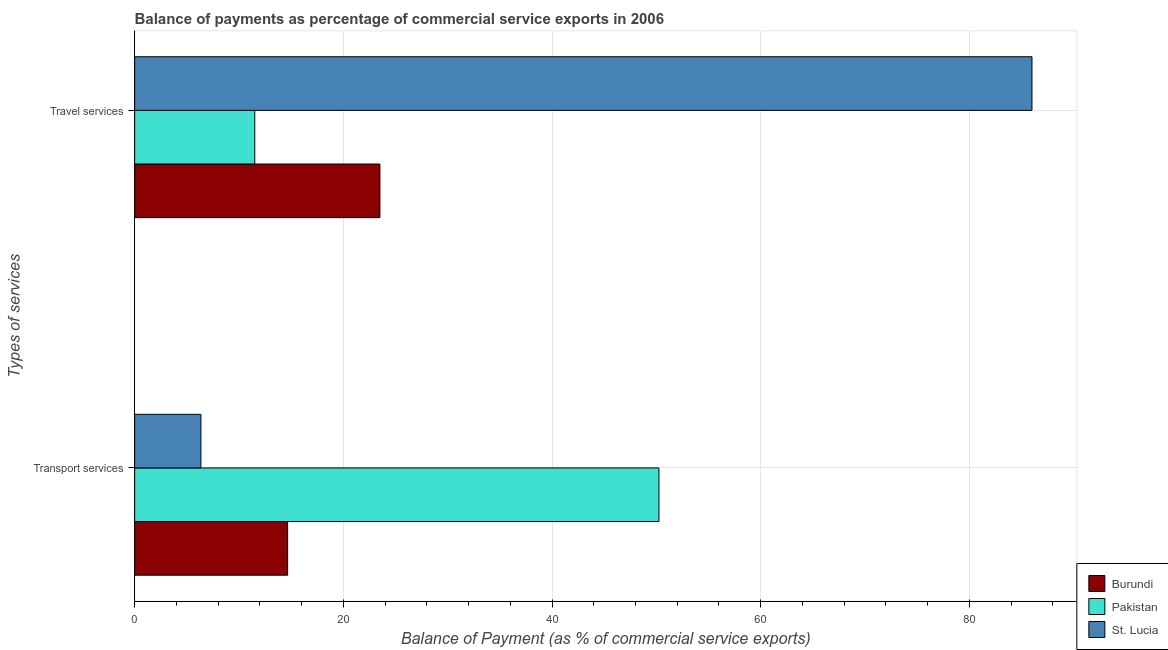How many different coloured bars are there?
Offer a very short reply. 3. How many groups of bars are there?
Give a very brief answer. 2. Are the number of bars per tick equal to the number of legend labels?
Your answer should be compact. Yes. What is the label of the 2nd group of bars from the top?
Your answer should be very brief. Transport services. What is the balance of payments of transport services in Pakistan?
Offer a very short reply. 50.25. Across all countries, what is the maximum balance of payments of travel services?
Provide a succinct answer. 86. Across all countries, what is the minimum balance of payments of travel services?
Offer a terse response. 11.51. In which country was the balance of payments of travel services maximum?
Give a very brief answer. St. Lucia. In which country was the balance of payments of transport services minimum?
Offer a terse response. St. Lucia. What is the total balance of payments of transport services in the graph?
Your answer should be compact. 71.26. What is the difference between the balance of payments of transport services in St. Lucia and that in Pakistan?
Give a very brief answer. -43.9. What is the difference between the balance of payments of travel services in St. Lucia and the balance of payments of transport services in Burundi?
Give a very brief answer. 71.34. What is the average balance of payments of travel services per country?
Your answer should be compact. 40.34. What is the difference between the balance of payments of transport services and balance of payments of travel services in Burundi?
Offer a terse response. -8.84. What is the ratio of the balance of payments of transport services in St. Lucia to that in Burundi?
Offer a very short reply. 0.43. Is the balance of payments of transport services in St. Lucia less than that in Burundi?
Ensure brevity in your answer.  Yes. In how many countries, is the balance of payments of travel services greater than the average balance of payments of travel services taken over all countries?
Keep it short and to the point. 1. What does the 3rd bar from the top in Transport services represents?
Offer a terse response. Burundi. What does the 3rd bar from the bottom in Transport services represents?
Provide a succinct answer. St. Lucia. How many bars are there?
Provide a succinct answer. 6. Are all the bars in the graph horizontal?
Offer a very short reply. Yes. How many countries are there in the graph?
Offer a terse response. 3. What is the difference between two consecutive major ticks on the X-axis?
Keep it short and to the point. 20. Are the values on the major ticks of X-axis written in scientific E-notation?
Make the answer very short. No. How are the legend labels stacked?
Keep it short and to the point. Vertical. What is the title of the graph?
Provide a succinct answer. Balance of payments as percentage of commercial service exports in 2006. What is the label or title of the X-axis?
Your answer should be very brief. Balance of Payment (as % of commercial service exports). What is the label or title of the Y-axis?
Your response must be concise. Types of services. What is the Balance of Payment (as % of commercial service exports) in Burundi in Transport services?
Provide a short and direct response. 14.66. What is the Balance of Payment (as % of commercial service exports) of Pakistan in Transport services?
Your answer should be very brief. 50.25. What is the Balance of Payment (as % of commercial service exports) of St. Lucia in Transport services?
Ensure brevity in your answer.  6.35. What is the Balance of Payment (as % of commercial service exports) in Burundi in Travel services?
Offer a terse response. 23.51. What is the Balance of Payment (as % of commercial service exports) in Pakistan in Travel services?
Your answer should be compact. 11.51. What is the Balance of Payment (as % of commercial service exports) in St. Lucia in Travel services?
Ensure brevity in your answer.  86. Across all Types of services, what is the maximum Balance of Payment (as % of commercial service exports) in Burundi?
Give a very brief answer. 23.51. Across all Types of services, what is the maximum Balance of Payment (as % of commercial service exports) in Pakistan?
Offer a terse response. 50.25. Across all Types of services, what is the maximum Balance of Payment (as % of commercial service exports) of St. Lucia?
Your response must be concise. 86. Across all Types of services, what is the minimum Balance of Payment (as % of commercial service exports) in Burundi?
Offer a very short reply. 14.66. Across all Types of services, what is the minimum Balance of Payment (as % of commercial service exports) of Pakistan?
Provide a succinct answer. 11.51. Across all Types of services, what is the minimum Balance of Payment (as % of commercial service exports) in St. Lucia?
Give a very brief answer. 6.35. What is the total Balance of Payment (as % of commercial service exports) of Burundi in the graph?
Offer a very short reply. 38.17. What is the total Balance of Payment (as % of commercial service exports) in Pakistan in the graph?
Your response must be concise. 61.76. What is the total Balance of Payment (as % of commercial service exports) in St. Lucia in the graph?
Give a very brief answer. 92.35. What is the difference between the Balance of Payment (as % of commercial service exports) of Burundi in Transport services and that in Travel services?
Provide a succinct answer. -8.84. What is the difference between the Balance of Payment (as % of commercial service exports) in Pakistan in Transport services and that in Travel services?
Provide a short and direct response. 38.74. What is the difference between the Balance of Payment (as % of commercial service exports) in St. Lucia in Transport services and that in Travel services?
Your answer should be compact. -79.65. What is the difference between the Balance of Payment (as % of commercial service exports) of Burundi in Transport services and the Balance of Payment (as % of commercial service exports) of Pakistan in Travel services?
Give a very brief answer. 3.15. What is the difference between the Balance of Payment (as % of commercial service exports) of Burundi in Transport services and the Balance of Payment (as % of commercial service exports) of St. Lucia in Travel services?
Give a very brief answer. -71.34. What is the difference between the Balance of Payment (as % of commercial service exports) of Pakistan in Transport services and the Balance of Payment (as % of commercial service exports) of St. Lucia in Travel services?
Offer a terse response. -35.75. What is the average Balance of Payment (as % of commercial service exports) in Burundi per Types of services?
Your answer should be very brief. 19.08. What is the average Balance of Payment (as % of commercial service exports) of Pakistan per Types of services?
Provide a short and direct response. 30.88. What is the average Balance of Payment (as % of commercial service exports) of St. Lucia per Types of services?
Your answer should be very brief. 46.18. What is the difference between the Balance of Payment (as % of commercial service exports) in Burundi and Balance of Payment (as % of commercial service exports) in Pakistan in Transport services?
Ensure brevity in your answer.  -35.59. What is the difference between the Balance of Payment (as % of commercial service exports) of Burundi and Balance of Payment (as % of commercial service exports) of St. Lucia in Transport services?
Provide a short and direct response. 8.31. What is the difference between the Balance of Payment (as % of commercial service exports) of Pakistan and Balance of Payment (as % of commercial service exports) of St. Lucia in Transport services?
Your response must be concise. 43.9. What is the difference between the Balance of Payment (as % of commercial service exports) in Burundi and Balance of Payment (as % of commercial service exports) in Pakistan in Travel services?
Ensure brevity in your answer.  11.99. What is the difference between the Balance of Payment (as % of commercial service exports) of Burundi and Balance of Payment (as % of commercial service exports) of St. Lucia in Travel services?
Ensure brevity in your answer.  -62.5. What is the difference between the Balance of Payment (as % of commercial service exports) in Pakistan and Balance of Payment (as % of commercial service exports) in St. Lucia in Travel services?
Make the answer very short. -74.49. What is the ratio of the Balance of Payment (as % of commercial service exports) of Burundi in Transport services to that in Travel services?
Provide a short and direct response. 0.62. What is the ratio of the Balance of Payment (as % of commercial service exports) in Pakistan in Transport services to that in Travel services?
Offer a terse response. 4.36. What is the ratio of the Balance of Payment (as % of commercial service exports) of St. Lucia in Transport services to that in Travel services?
Offer a terse response. 0.07. What is the difference between the highest and the second highest Balance of Payment (as % of commercial service exports) in Burundi?
Your answer should be very brief. 8.84. What is the difference between the highest and the second highest Balance of Payment (as % of commercial service exports) in Pakistan?
Give a very brief answer. 38.74. What is the difference between the highest and the second highest Balance of Payment (as % of commercial service exports) in St. Lucia?
Give a very brief answer. 79.65. What is the difference between the highest and the lowest Balance of Payment (as % of commercial service exports) of Burundi?
Your response must be concise. 8.84. What is the difference between the highest and the lowest Balance of Payment (as % of commercial service exports) of Pakistan?
Your response must be concise. 38.74. What is the difference between the highest and the lowest Balance of Payment (as % of commercial service exports) of St. Lucia?
Offer a terse response. 79.65. 